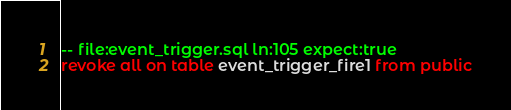Convert code to text. <code><loc_0><loc_0><loc_500><loc_500><_SQL_>-- file:event_trigger.sql ln:105 expect:true
revoke all on table event_trigger_fire1 from public
</code> 